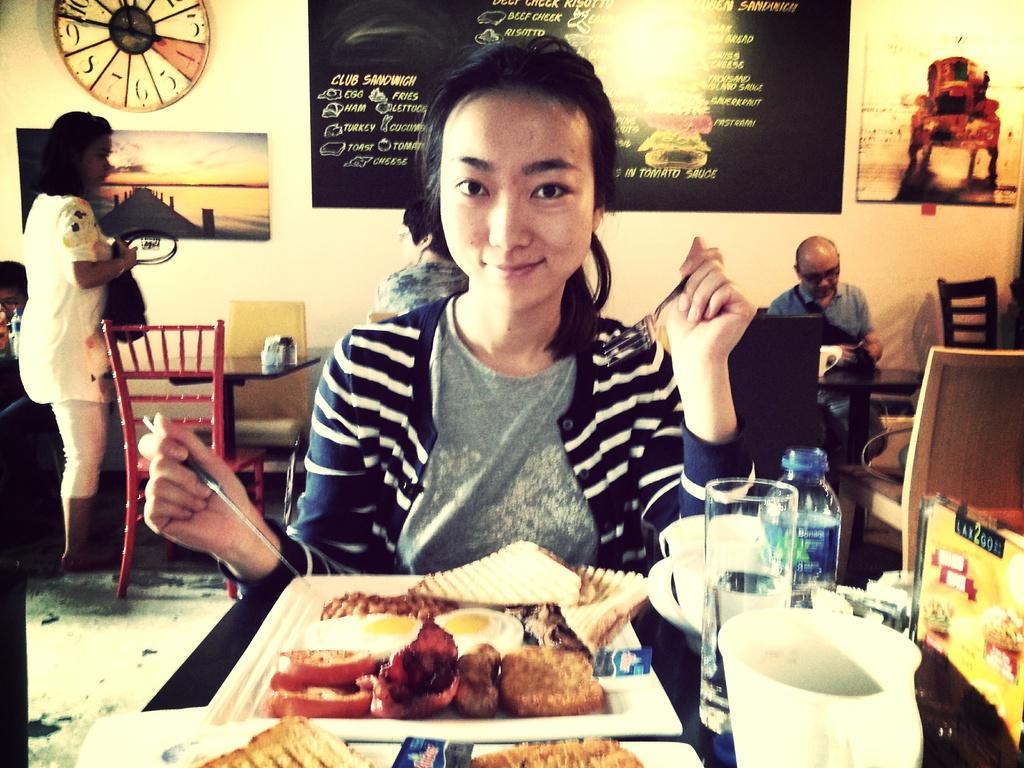Please provide a concise description of this image. In this picture we can see a woman sitting and holding a knife, fork with her hands and smiling and in front of her we can see food items, trays, glass, bottle, cup on the table and in the background we can see some people, tables, chairs, posters on the wall and some objects. 